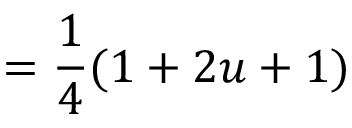Convert formula to latex. <formula><loc_0><loc_0><loc_500><loc_500>= { \frac { 1 } { 4 } } ( 1 + 2 u + 1 )</formula> 